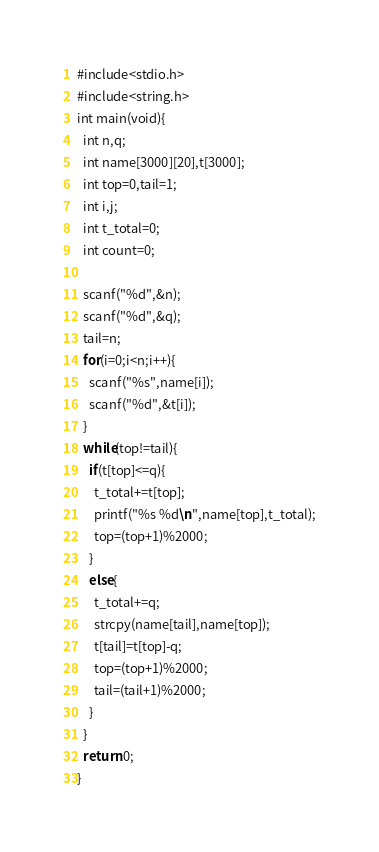<code> <loc_0><loc_0><loc_500><loc_500><_C_>#include<stdio.h>
#include<string.h>
int main(void){
  int n,q;
  int name[3000][20],t[3000];
  int top=0,tail=1;
  int i,j;
  int t_total=0;
  int count=0;

  scanf("%d",&n);
  scanf("%d",&q);
  tail=n;
  for(i=0;i<n;i++){
    scanf("%s",name[i]);
    scanf("%d",&t[i]);
  }
  while(top!=tail){
    if(t[top]<=q){
      t_total+=t[top];
      printf("%s %d\n",name[top],t_total);
      top=(top+1)%2000;
    }
    else{
      t_total+=q;
      strcpy(name[tail],name[top]);
      t[tail]=t[top]-q;
      top=(top+1)%2000;
      tail=(tail+1)%2000;
    }
  }
  return 0;
}</code> 